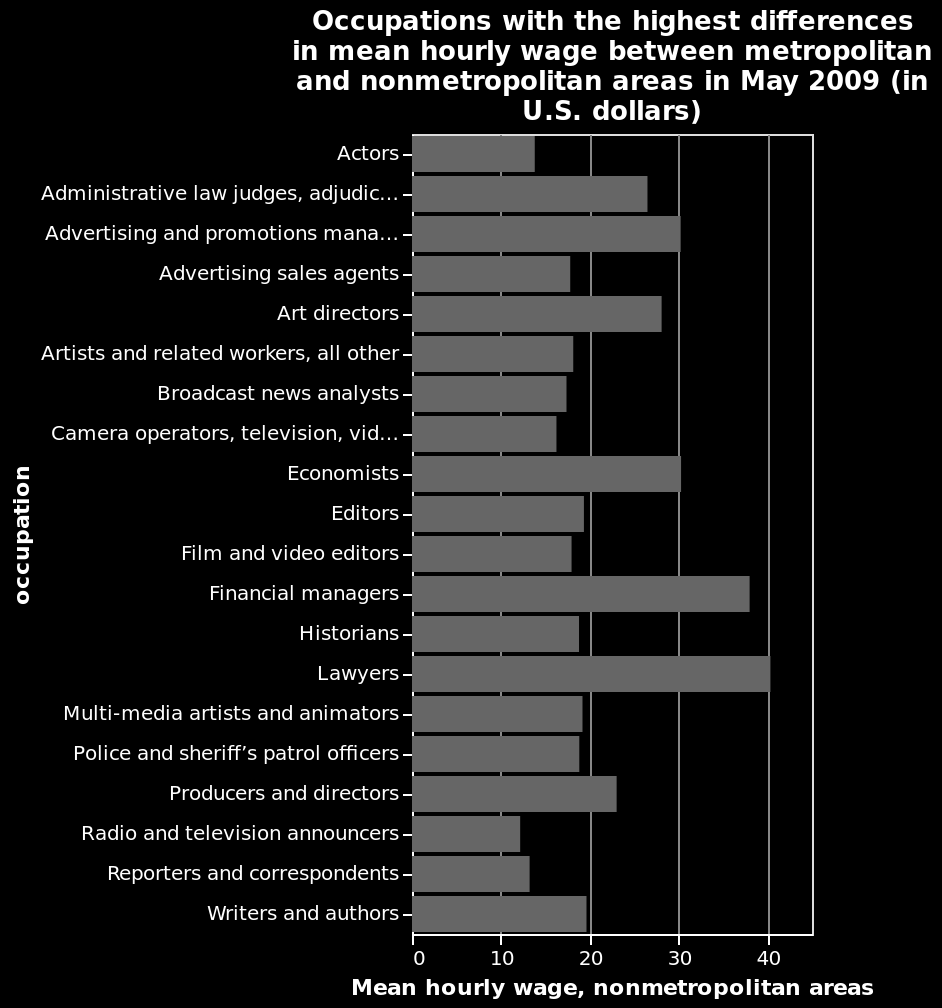<image>
Which occupation receives the lowest hourly rate?  Radio/TV presenters receive the lowest hourly rate. Offer a thorough analysis of the image. Lawyers have the highest wage difference between metropolitan and nonmetropolitan areas. Reporters have the lowest difference in wages. The highest (layer) and the lowest difference (reporters and correspondents) in hourly wage have a difference of around 28. Most occupations has a wage difference of around 20. The wages of financial managers and lawyers are extremely increased in metropolitan areas. Which occupation receives the highest hourly rate?  Lawyers receive the highest hourly rate. 